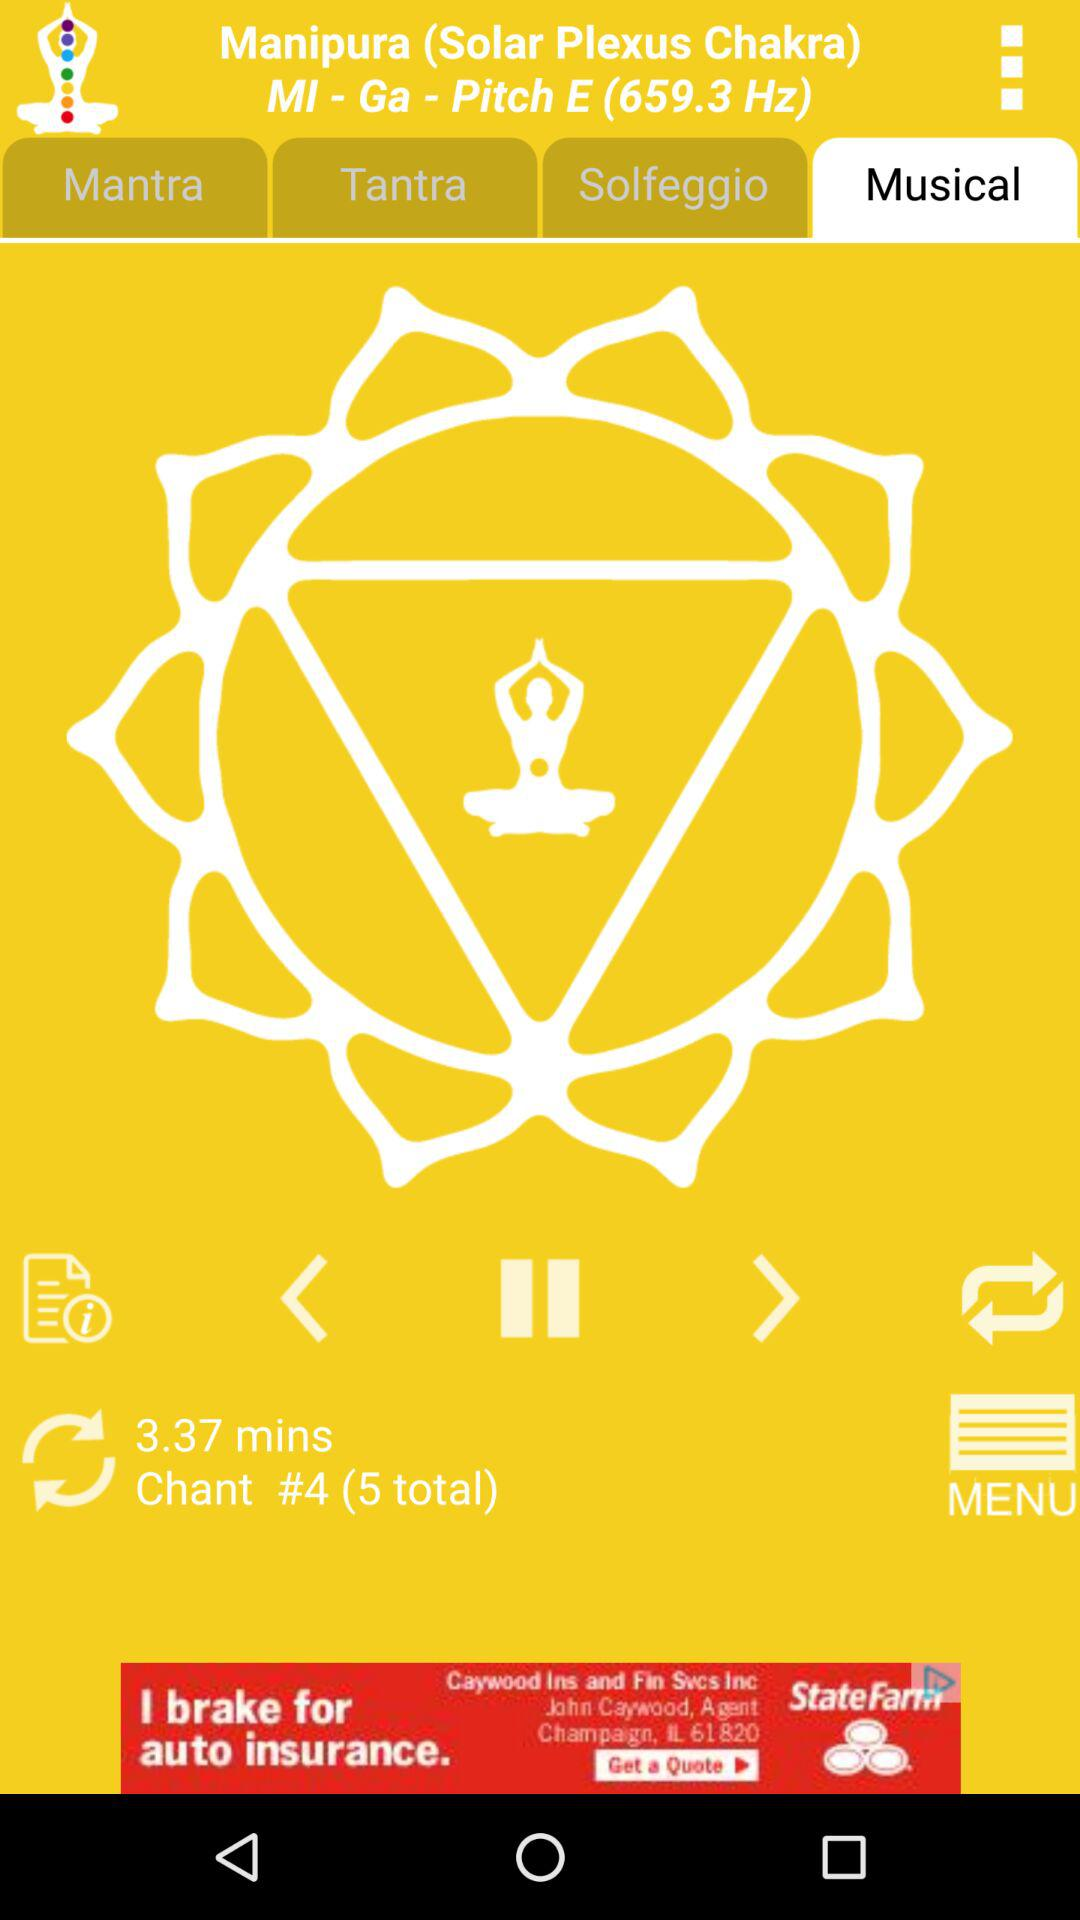What is the duration of Chant #4? The duration of Chant #4 is 3.37 minutes. 